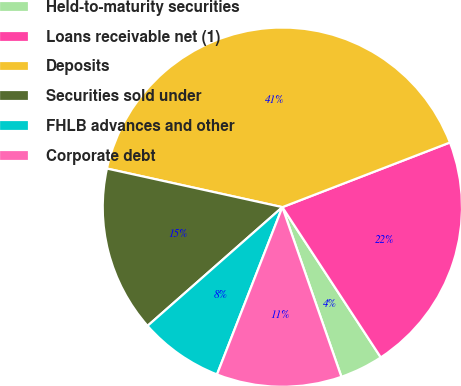Convert chart. <chart><loc_0><loc_0><loc_500><loc_500><pie_chart><fcel>Held-to-maturity securities<fcel>Loans receivable net (1)<fcel>Deposits<fcel>Securities sold under<fcel>FHLB advances and other<fcel>Corporate debt<nl><fcel>3.9%<fcel>21.63%<fcel>40.69%<fcel>14.94%<fcel>7.58%<fcel>11.26%<nl></chart> 